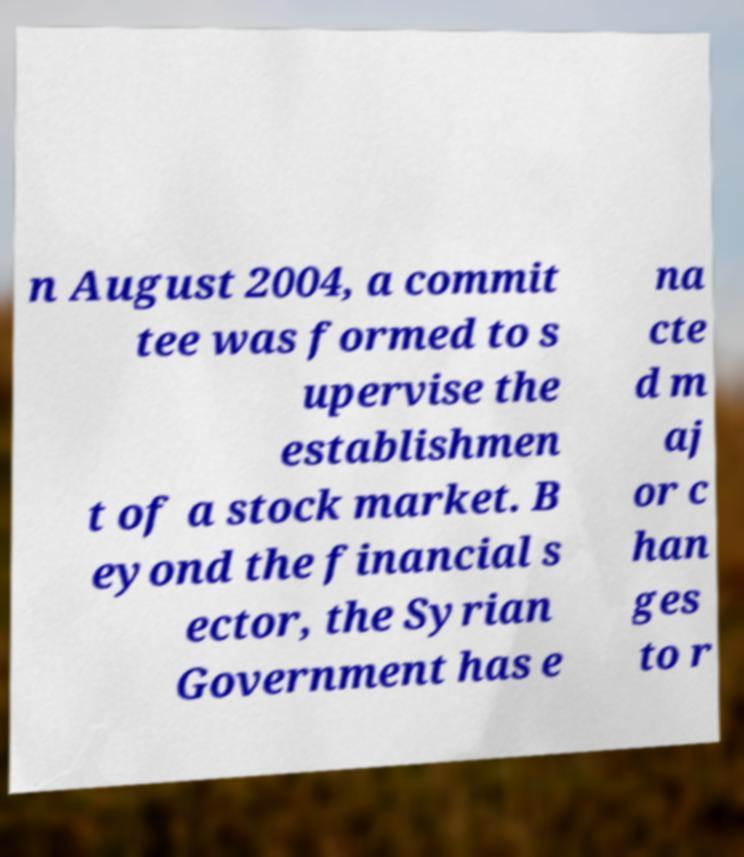Please identify and transcribe the text found in this image. n August 2004, a commit tee was formed to s upervise the establishmen t of a stock market. B eyond the financial s ector, the Syrian Government has e na cte d m aj or c han ges to r 